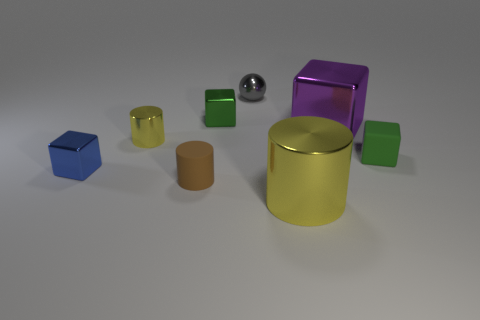Add 2 big blocks. How many objects exist? 10 Subtract all balls. How many objects are left? 7 Subtract 0 gray cubes. How many objects are left? 8 Subtract all small brown rubber things. Subtract all green matte blocks. How many objects are left? 6 Add 8 blue metallic objects. How many blue metallic objects are left? 9 Add 3 matte objects. How many matte objects exist? 5 